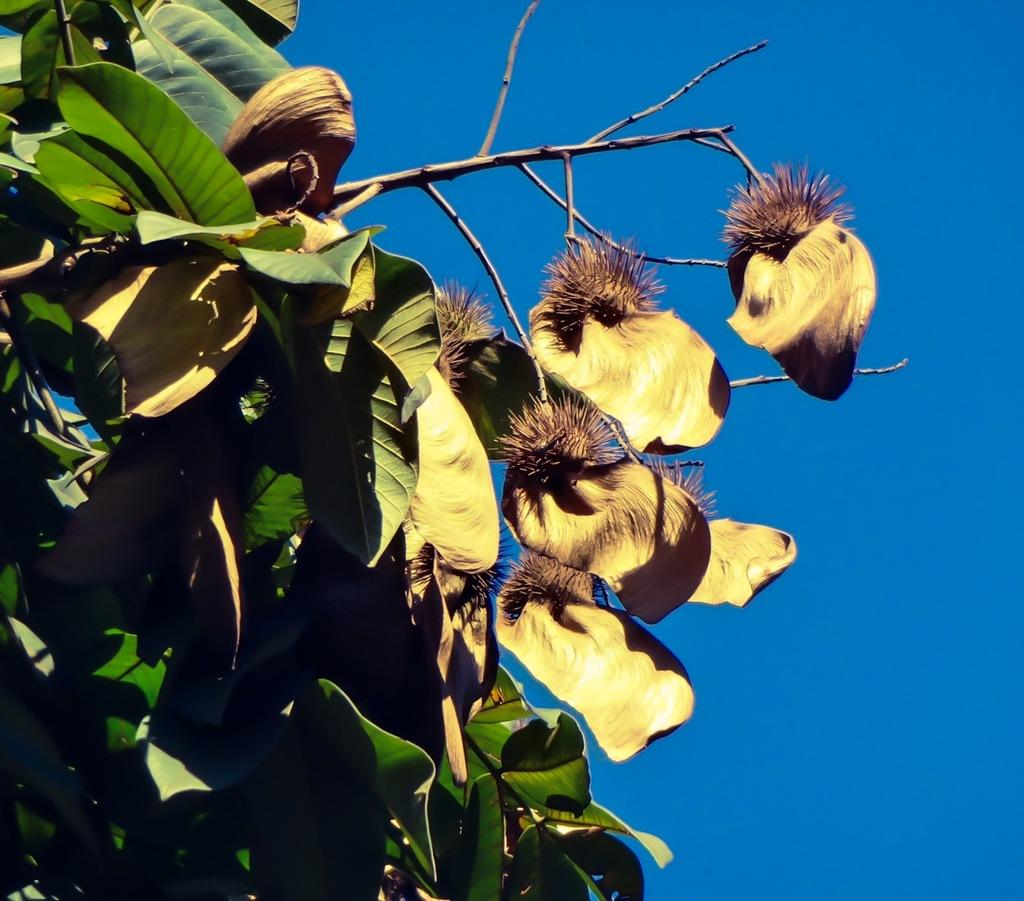What type of plant can be seen in the image? There is a tree in the image. What part of the natural environment is visible in the image? The sky is visible in the background of the image. What type of rice is being cooked in the image? There is no rice present in the image; it features a tree and the sky. Can you see a zebra grazing near the tree in the image? There is no zebra present in the image; it only features a tree and the sky. 